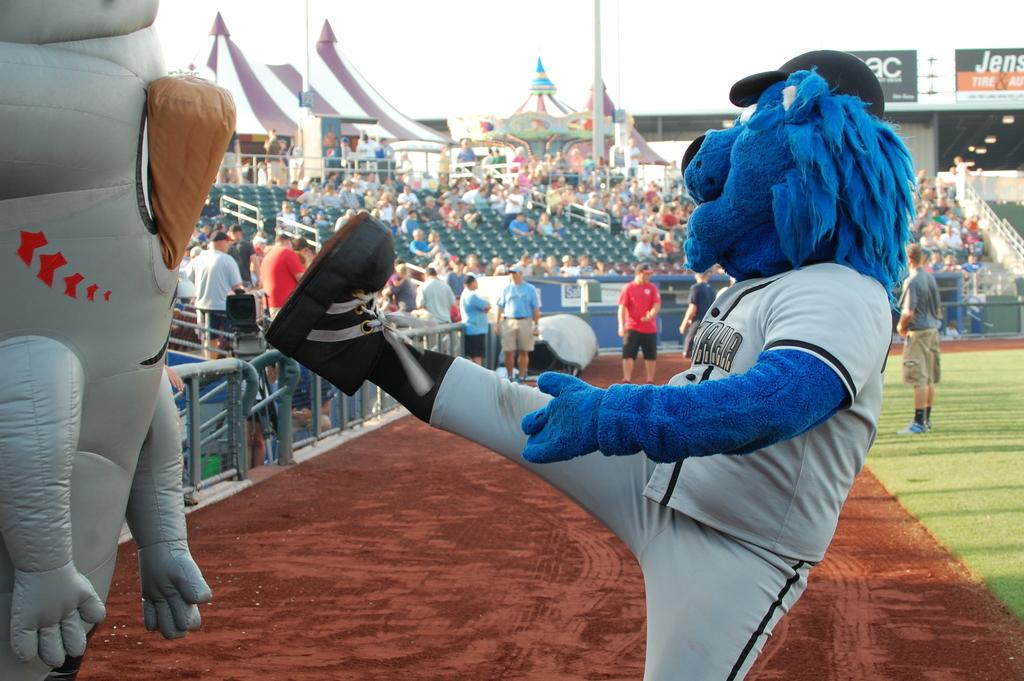<image>
Create a compact narrative representing the image presented. A baseball team mascot holding his foot up into the crowd sitting in the bleachers while banners hang in the distance with Tune on one of them. 